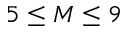<formula> <loc_0><loc_0><loc_500><loc_500>5 \leq M \leq 9</formula> 